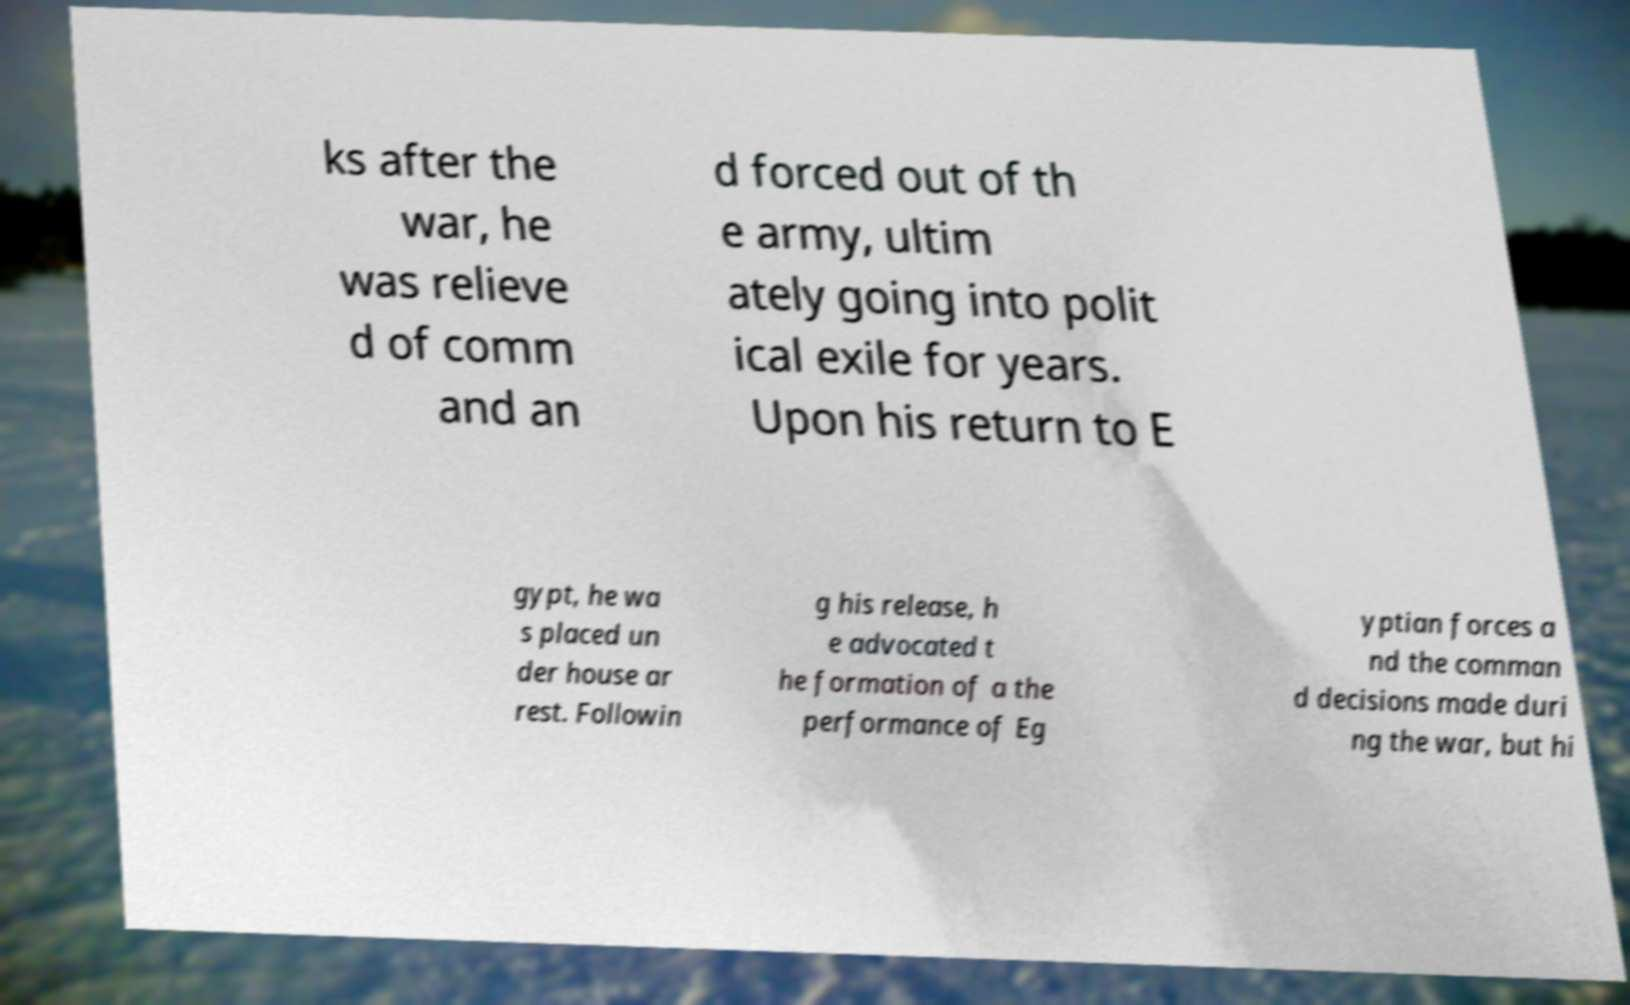For documentation purposes, I need the text within this image transcribed. Could you provide that? ks after the war, he was relieve d of comm and an d forced out of th e army, ultim ately going into polit ical exile for years. Upon his return to E gypt, he wa s placed un der house ar rest. Followin g his release, h e advocated t he formation of a the performance of Eg yptian forces a nd the comman d decisions made duri ng the war, but hi 